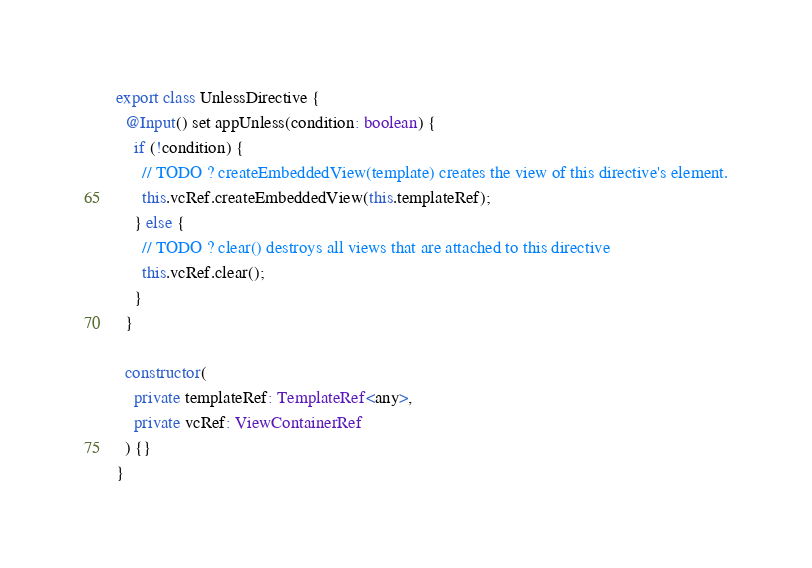<code> <loc_0><loc_0><loc_500><loc_500><_TypeScript_>export class UnlessDirective {
  @Input() set appUnless(condition: boolean) {
    if (!condition) {
      // TODO ? createEmbeddedView(template) creates the view of this directive's element.
      this.vcRef.createEmbeddedView(this.templateRef);
    } else {
      // TODO ? clear() destroys all views that are attached to this directive
      this.vcRef.clear();
    }
  }

  constructor(
    private templateRef: TemplateRef<any>,
    private vcRef: ViewContainerRef
  ) {}
}
</code> 